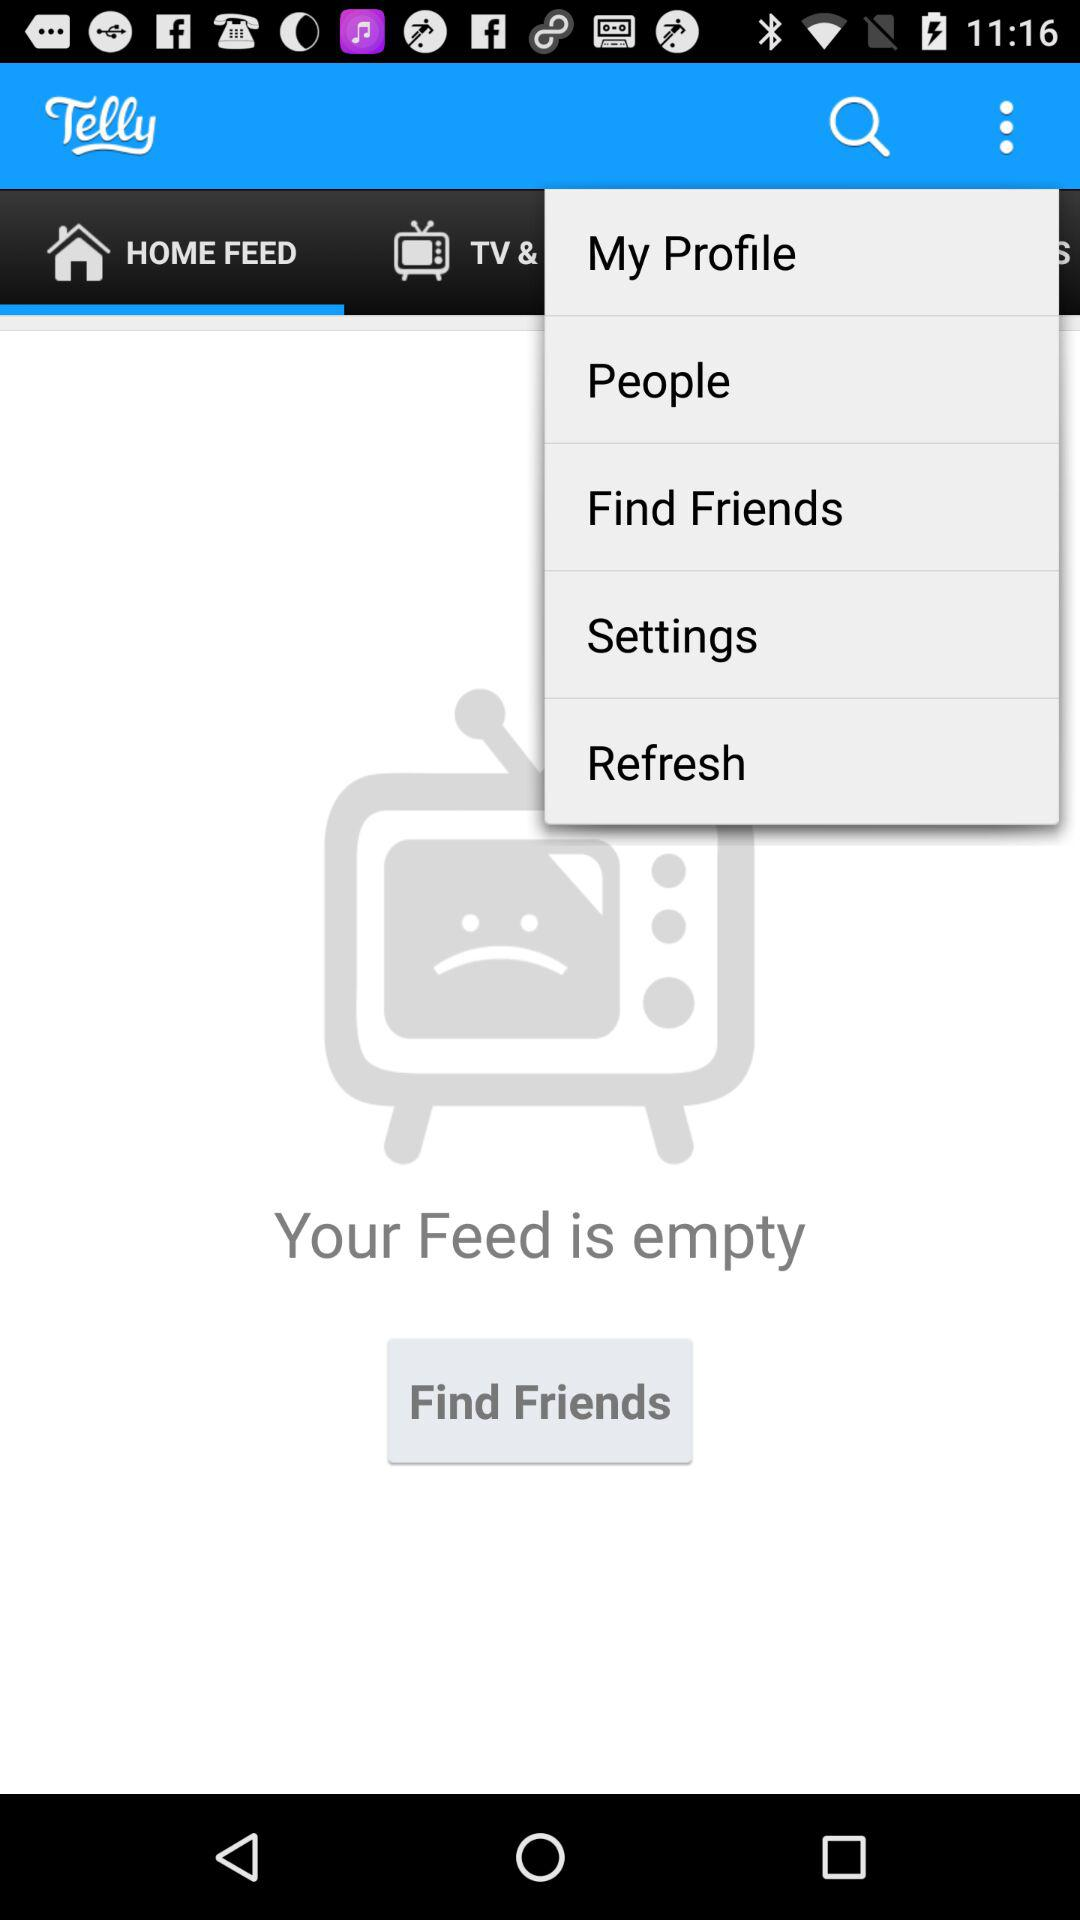How many notifications are there in "Settings"?
When the provided information is insufficient, respond with <no answer>. <no answer> 